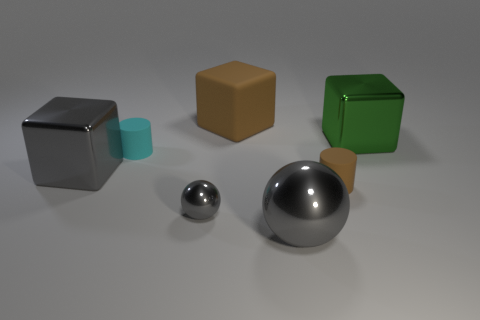Add 3 green blocks. How many objects exist? 10 Subtract all balls. How many objects are left? 5 Subtract all cyan cylinders. How many cylinders are left? 1 Subtract all big metal blocks. How many blocks are left? 1 Subtract 0 green spheres. How many objects are left? 7 Subtract 2 cubes. How many cubes are left? 1 Subtract all blue balls. Subtract all green blocks. How many balls are left? 2 Subtract all green spheres. How many blue cylinders are left? 0 Subtract all small gray balls. Subtract all tiny brown cylinders. How many objects are left? 5 Add 3 small things. How many small things are left? 6 